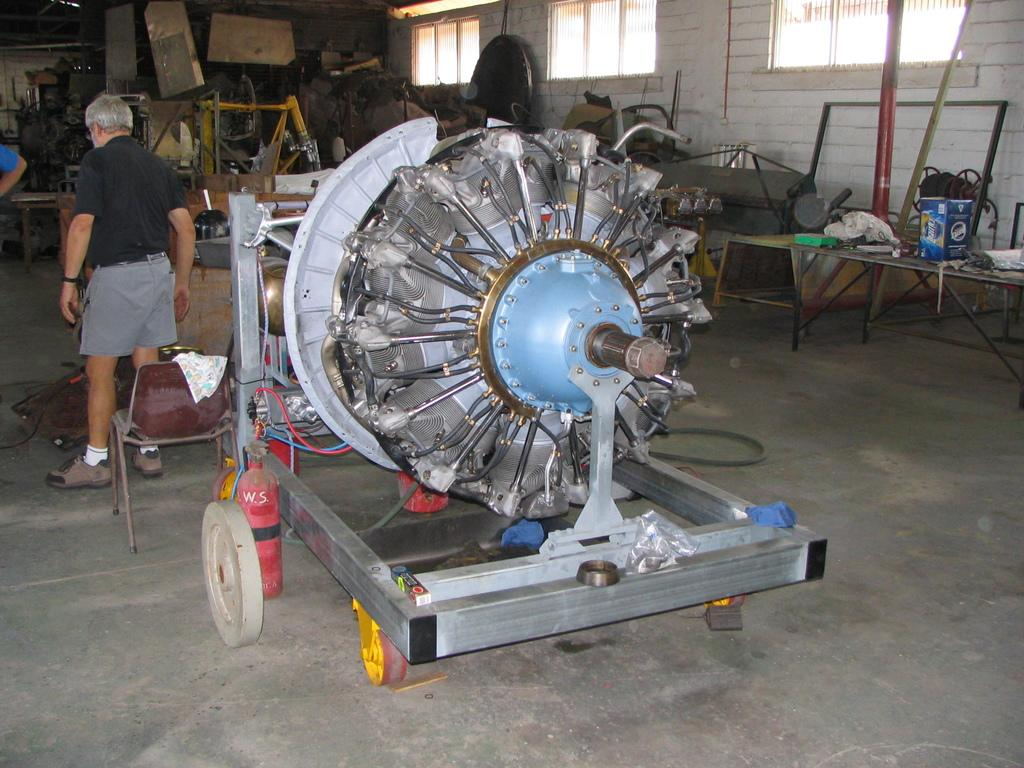What is there is a motor in the middle of the image, what is it attached to? The motor is not attached to anything visible in the image. What is the man on the left side of the image doing? The provided facts do not specify what the man is doing. What color is the man's t-shirt? The man is wearing a black t-shirt. How many bikes are parked next to the man in the image? There are no bikes present in the image. What type of flesh can be seen on the man's arm in the image? There is no flesh visible on the man's arm in the image, as he is wearing a t-shirt. What is the man's account balance in the image? There is no information about the man's account balance in the image. 